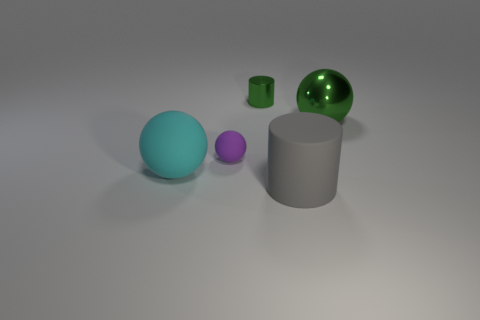Does the tiny cylinder have the same material as the big object to the left of the big cylinder? No, the tiny cylinder appears to have a matte, opaque surface characteristic of materials like plastic or painted metal, while the larger object on the left side of the big cylinder seems to possess a reflective surface that could suggest it's made of a polished metal or similar reflective material. 